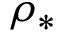Convert formula to latex. <formula><loc_0><loc_0><loc_500><loc_500>\rho _ { * }</formula> 